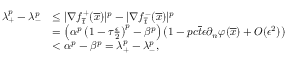Convert formula to latex. <formula><loc_0><loc_0><loc_500><loc_500>\begin{array} { r l } { \lambda _ { + } ^ { p } - \lambda _ { - } ^ { p } } & { \leq | \nabla f _ { \overline { t } } ^ { + } ( \overline { x } ) | ^ { p } - | \nabla f _ { \overline { t } } ^ { - } ( \overline { x } ) | ^ { p } } \\ & { = \left ( \alpha ^ { p } \left ( 1 - \tau \frac { \epsilon } { 2 } \right ) ^ { p } - \beta ^ { p } \right ) \left ( 1 - p c \overline { t } \epsilon \partial _ { n } \varphi ( \overline { x } ) + O ( \epsilon ^ { 2 } ) \right ) } \\ & { < \alpha ^ { p } - \beta ^ { p } = \lambda _ { + } ^ { p } - \lambda _ { - } ^ { p } , } \end{array}</formula> 